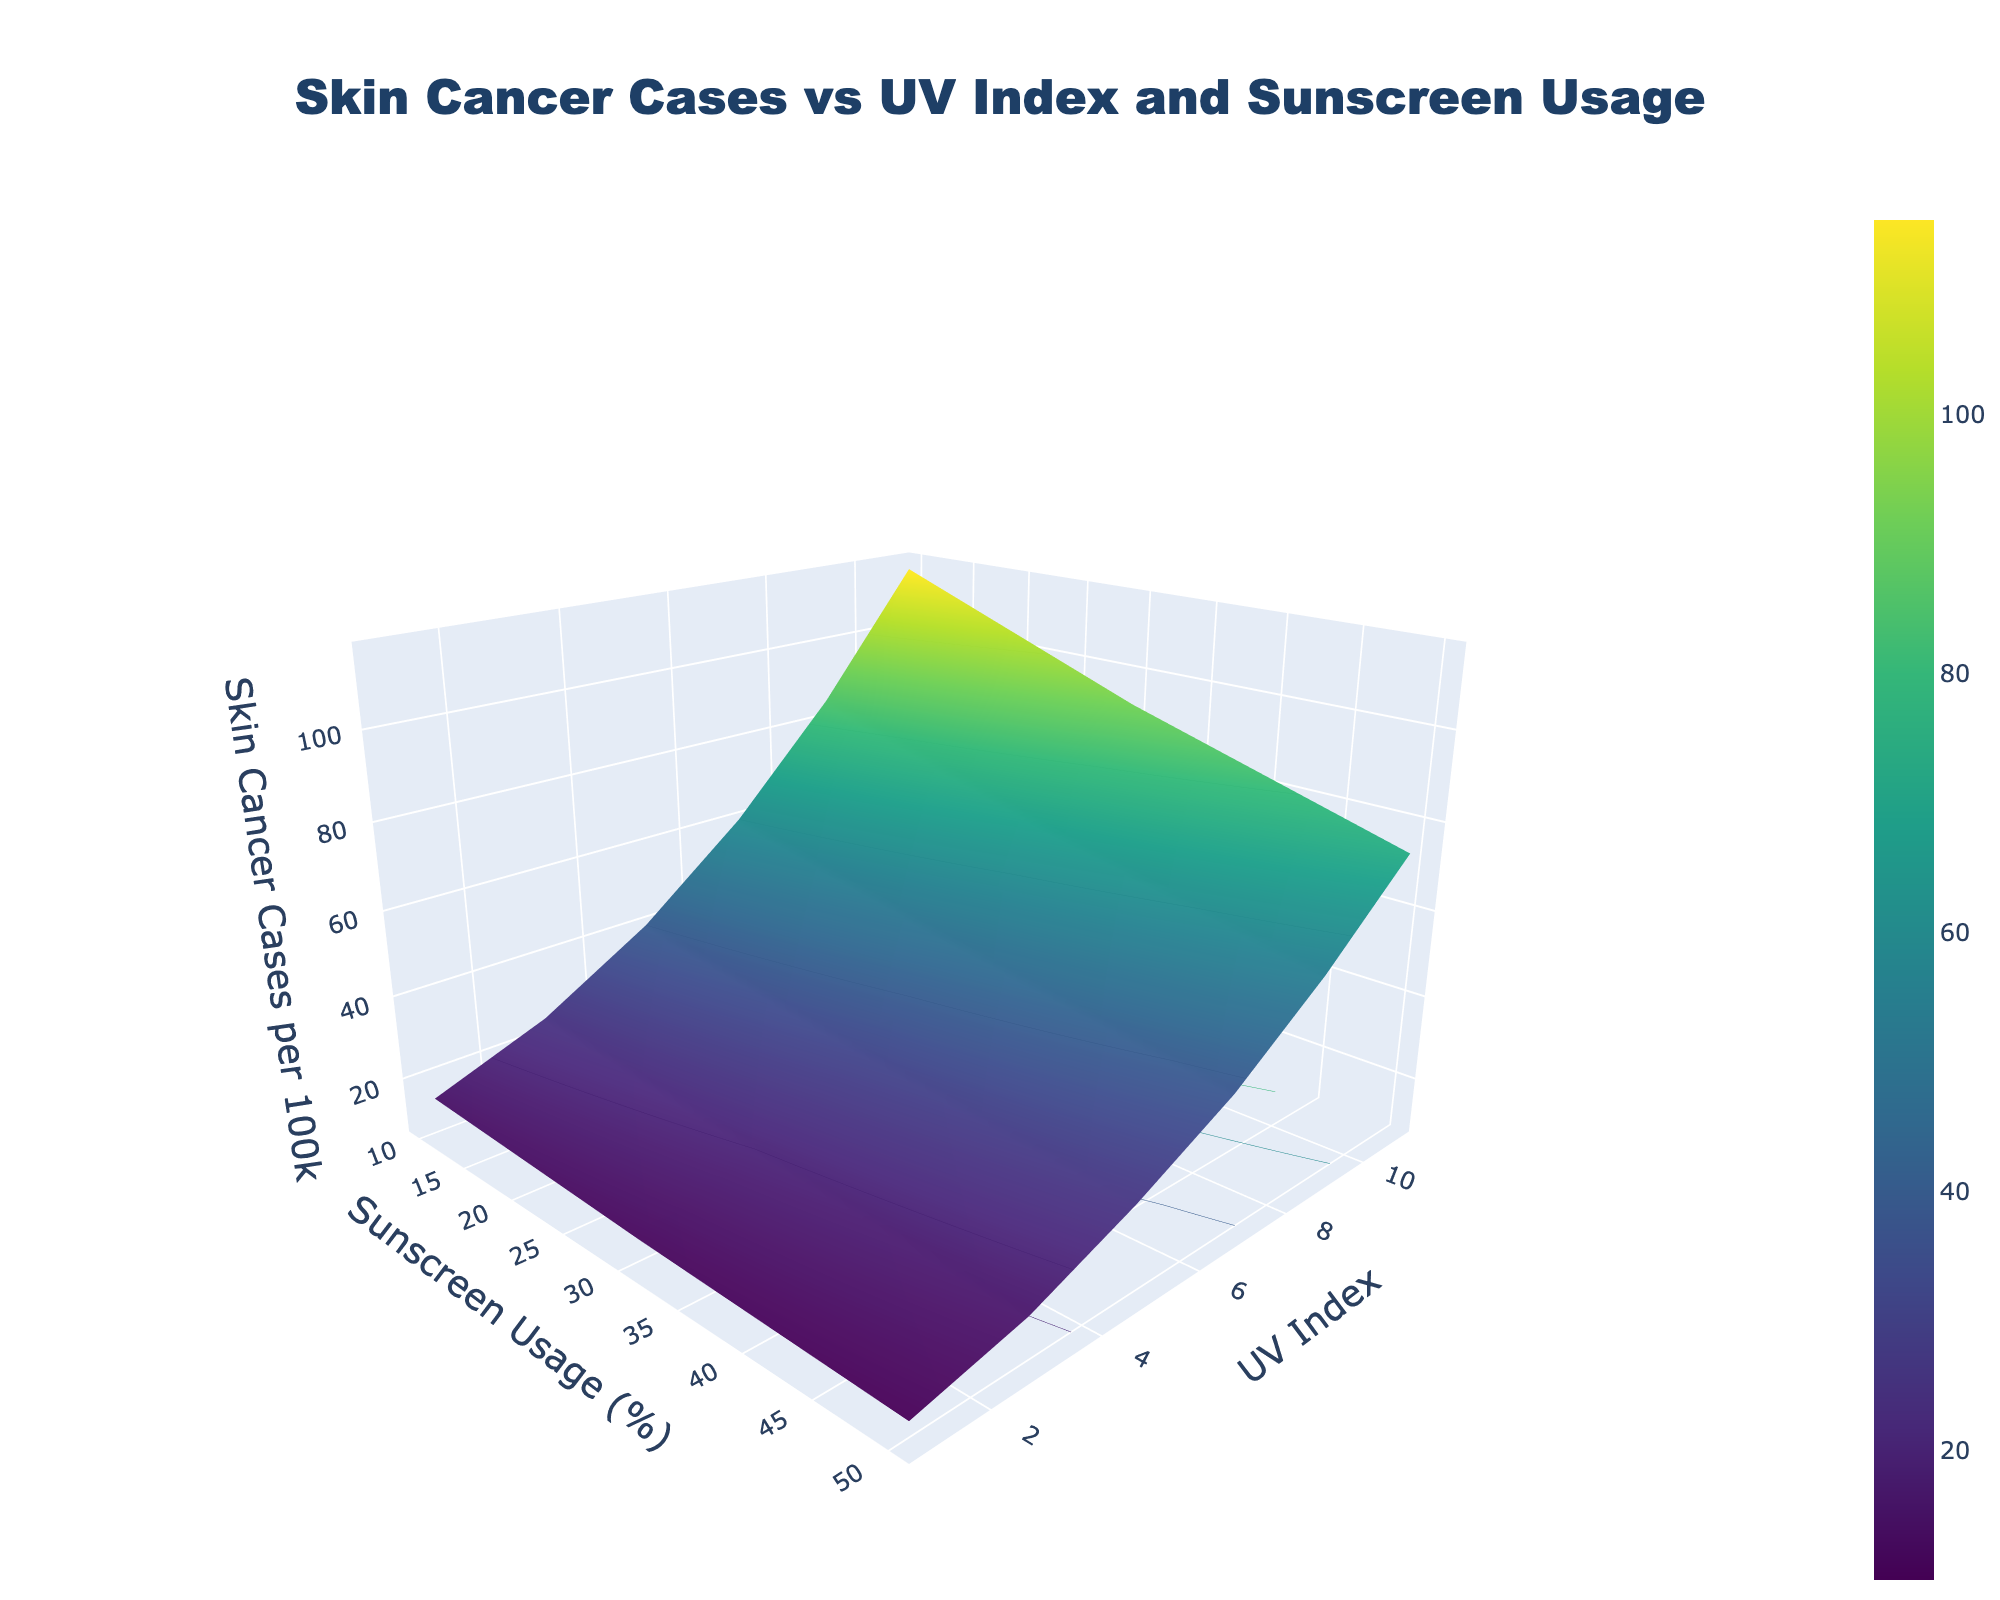What's the title of the figure? The title is prominently displayed at the top center of the figure. It reads "Skin Cancer Cases vs UV Index and Sunscreen Usage".
Answer: Skin Cancer Cases vs UV Index and Sunscreen Usage What are the axes titles for the plot? The x-axis is titled "Sunscreen Usage (%)", the y-axis is titled "UV Index", and the z-axis is titled "Skin Cancer Cases per 100k".
Answer: Sunscreen Usage (%), UV Index, Skin Cancer Cases per 100k What UV Index value corresponds to the highest Skin Cancer Cases per 100k, assuming minimal sunscreen usage? Based on the 3D surface plot, the highest point on the z-axis (Skin Cancer Cases per 100k) is at UV Index 11 with Sunscreen Usage at 10%.
Answer: UV Index 11 At UV Index of 5, how much does the skin cancer cases per 100k decrease from 10% to 50% sunscreen usage? From the plot, at UV Index 5, Skin Cancer Cases per 100k is 40 at 10% sunscreen usage and 26 at 50%. The decrease is 40 - 26 = 14.
Answer: 14 Comparing sunscreen usage of 10% and 30%, at which UV index is the decrease in skin cancer cases per 100k the greatest? The greatest decrease in Skin Cancer Cases between 10% and 30% sunscreen usage can be observed at UV Index 11, where it decreases from 115 to 92, a difference of 23.
Answer: UV Index 11 What trend can you observe in Skin Cancer Cases as UV Index increases at a constant Sunscreen Usage of 50%? As UV Index increases, Skin Cancer Cases per 100k also increase at a constant Sunscreen Usage of 50%, but the increase is significantly slower compared to lower sunscreen usages.
Answer: Trend of increase with slower rate How many significant contour zones can you discern from the plot, based on color changes? There are approximately five significant contour zones discerned from the variance in colors, indicating different ranges of Skin Cancer Cases per 100k.
Answer: Five What's the average Skin Cancer Cases per 100k for UV Index 9 across all sunscreen usage levels? For UV Index 9, the Skin Cancer Cases per 100k are 85 (10%), 68 (30%), and 54 (50%). The average is (85 + 68 + 54) / 3 = 69.
Answer: 69 Is there a UV Index value where Skin Cancer Cases per 100k stays approximately constant across all sunscreen usage levels? UV Index 1 shows a relatively constant number of Skin Cancer Cases per 100k across different sunscreen usage levels, ranging from 10 to 15.
Answer: UV Index 1 